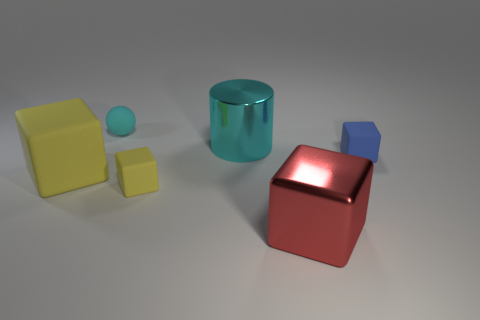Subtract all rubber cubes. How many cubes are left? 1 Subtract all cylinders. How many objects are left? 5 Add 2 red metallic cubes. How many objects exist? 8 Subtract all yellow blocks. How many blocks are left? 2 Subtract 1 cubes. How many cubes are left? 3 Subtract all gray blocks. Subtract all purple cylinders. How many blocks are left? 4 Subtract all cyan cylinders. How many yellow blocks are left? 2 Subtract all red cubes. Subtract all metallic objects. How many objects are left? 3 Add 6 tiny yellow matte cubes. How many tiny yellow matte cubes are left? 7 Add 6 large yellow shiny cubes. How many large yellow shiny cubes exist? 6 